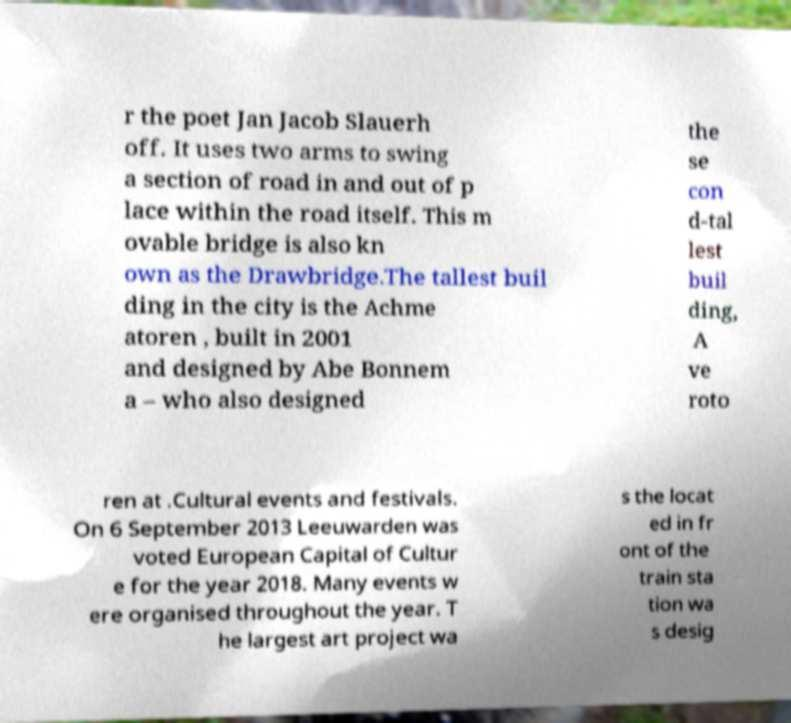Could you assist in decoding the text presented in this image and type it out clearly? r the poet Jan Jacob Slauerh off. It uses two arms to swing a section of road in and out of p lace within the road itself. This m ovable bridge is also kn own as the Drawbridge.The tallest buil ding in the city is the Achme atoren , built in 2001 and designed by Abe Bonnem a – who also designed the se con d-tal lest buil ding, A ve roto ren at .Cultural events and festivals. On 6 September 2013 Leeuwarden was voted European Capital of Cultur e for the year 2018. Many events w ere organised throughout the year. T he largest art project wa s the locat ed in fr ont of the train sta tion wa s desig 